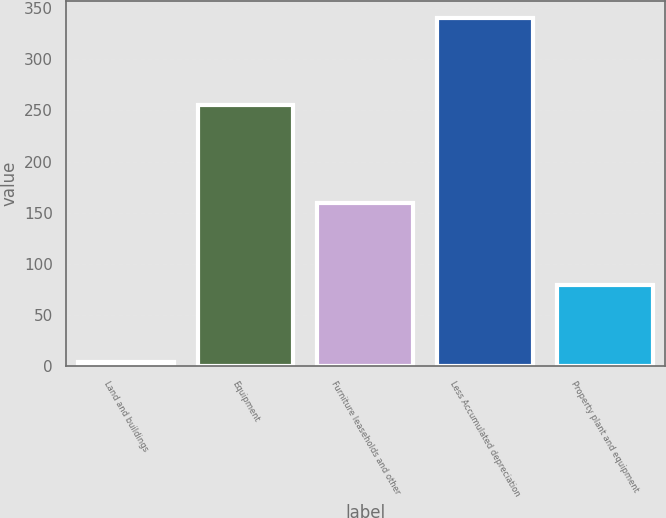<chart> <loc_0><loc_0><loc_500><loc_500><bar_chart><fcel>Land and buildings<fcel>Equipment<fcel>Furniture leaseholds and other<fcel>Less Accumulated depreciation<fcel>Property plant and equipment<nl><fcel>4.5<fcel>255.1<fcel>159.3<fcel>339.9<fcel>79<nl></chart> 